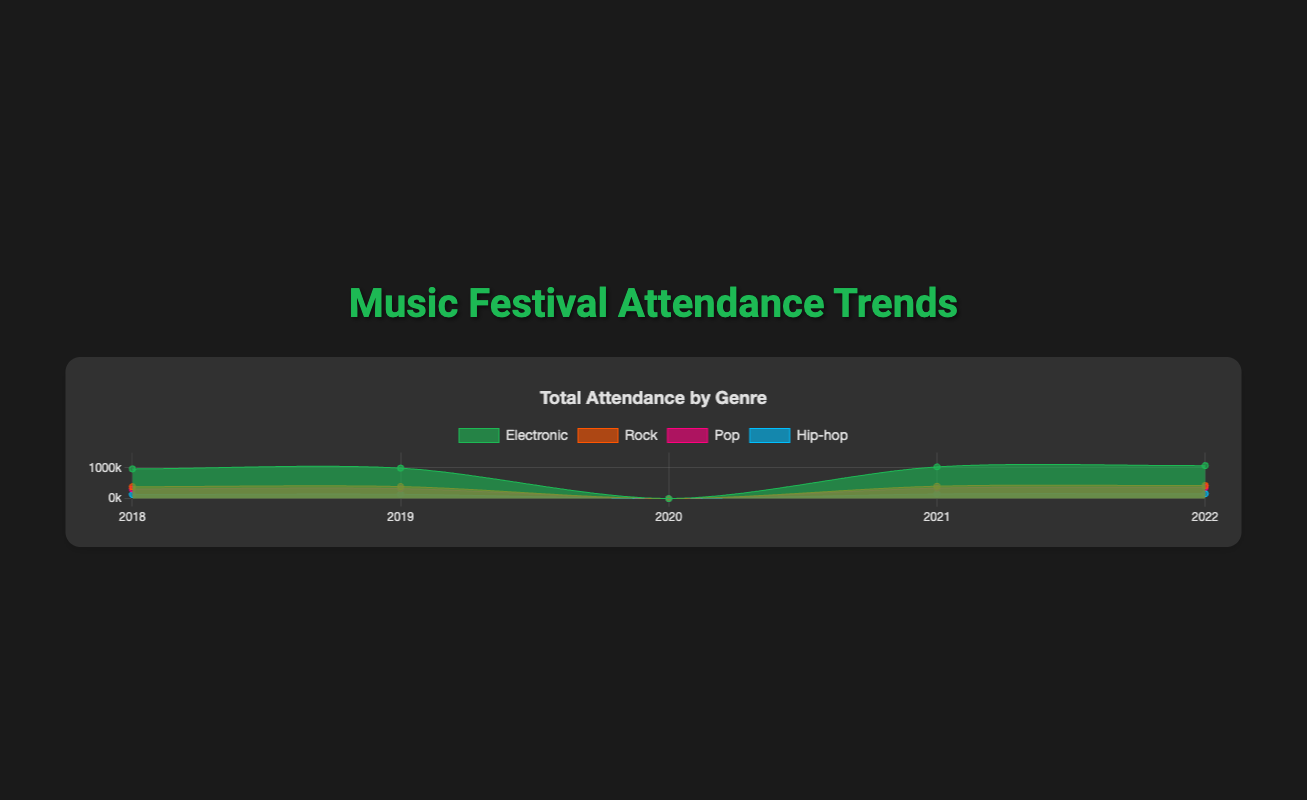What's the title of the chart? The title of the chart is displayed at the top of the figure in bold.
Answer: Music Festival Attendance Trends Which genre has the highest attendance in 2022? By looking at the endpoint of each genre's area in the year 2022, the one with the highest peak indicates the genre with the highest attendance.
Answer: Electronic Which year had the lowest total attendance across all genres? By examining the area heights across all genres for each year, 2020 has no attendance due to COVID-19 cancellations, making it the lowest.
Answer: 2020 What is the overall trend for Rock festivals from 2018 to 2022? Looking at the area representing Rock festivals, you can see a slight increase in attendance from 2018 to 2019, no attendance in 2020, and a steady rise from 2021 to 2022.
Answer: Increasing How does the attendance trend of Pop compare to Hip-hop from 2018 to 2022? Both genres show increasing trends, with a drop to zero in 2020. Pop shows a larger increase in attendance compared to Hip-hop, especially evident in 2022.
Answer: Pop grows more Which festival within Electronic genre had the highest attendance in 2019? Within the Electronic genre, check each festival's attendance for the year 2019. Tomorrowland had 410,000, Ultra Music Festival had 170,000, and Electric Daisy Carnival had 415,000.
Answer: Electric Daisy Carnival How does the attendance at Coachella in 2022 compare to Glastonbury in 2022? Looking at the endpoints for Coachella and Glastonbury in the year 2022, Coachella's attendance is higher.
Answer: Coachella is higher What is the difference in attendance between the highest and lowest festivals in 2022 within Hip-hop genre? In 2022, Rolling Loud had 65,000 attendees and KAABOO/Made in America each had 47,000. The difference is 65,000 - 47,000 = 18,000.
Answer: 18,000 What can you infer about the impact of COVID-19 on music festivals from the chart? In 2020, there is no attendance shown for any genre, indicating that COVID-19 significantly impacted the ability to hold these festivals.
Answer: All festivals were canceled What is the color used to represent the Electronic genre in the chart? The color of each genre is encoded visually. The Electronic genre uses a shade of green.
Answer: Green 